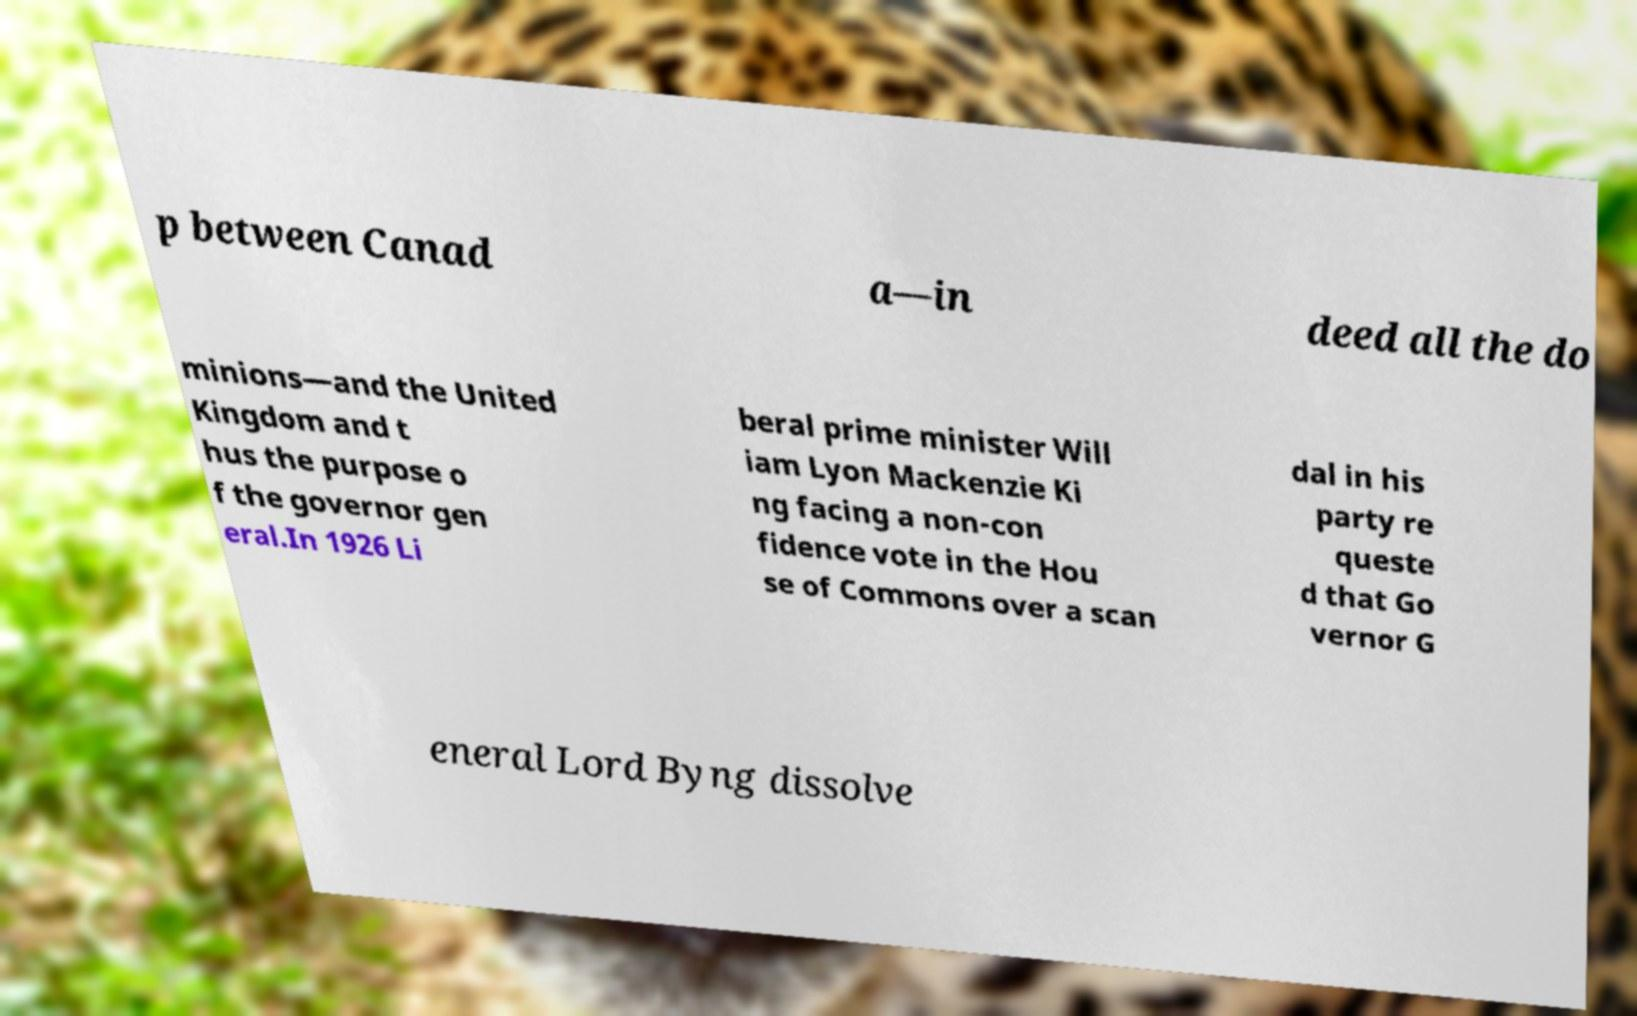I need the written content from this picture converted into text. Can you do that? p between Canad a—in deed all the do minions—and the United Kingdom and t hus the purpose o f the governor gen eral.In 1926 Li beral prime minister Will iam Lyon Mackenzie Ki ng facing a non-con fidence vote in the Hou se of Commons over a scan dal in his party re queste d that Go vernor G eneral Lord Byng dissolve 